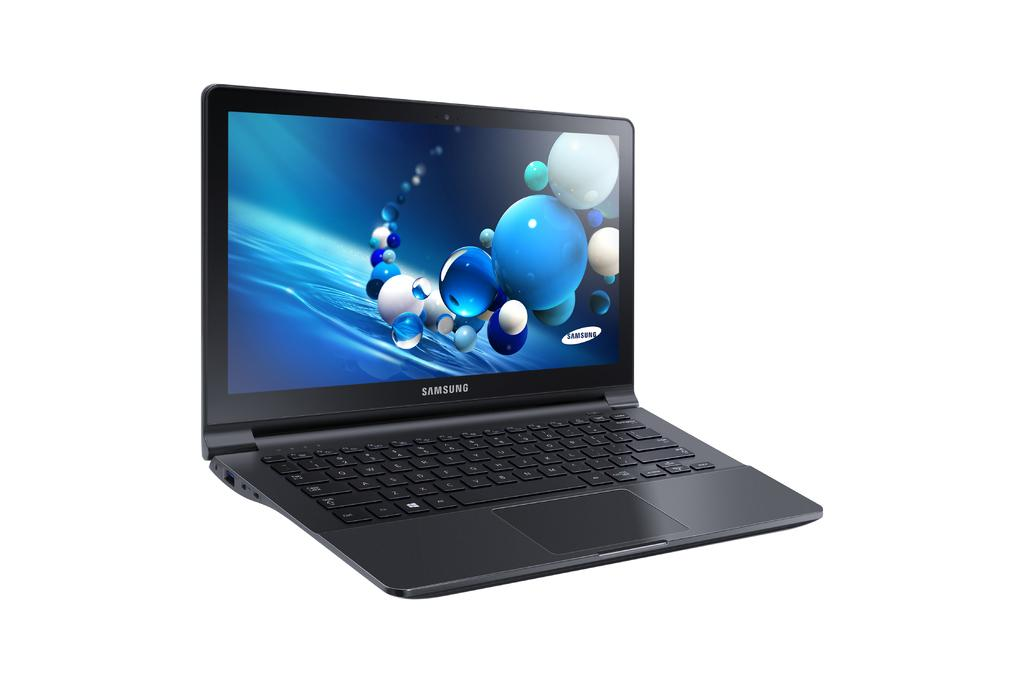Provide a one-sentence caption for the provided image. An adverisement showing only a Samsung laptop computer. 